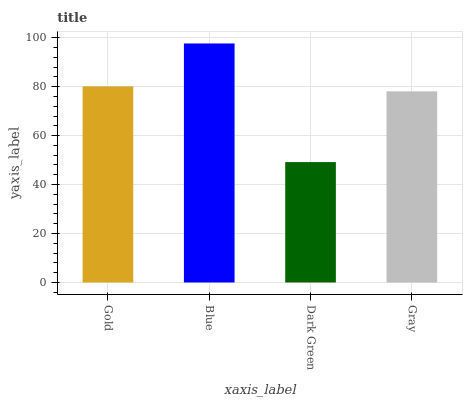Is Dark Green the minimum?
Answer yes or no. Yes. Is Blue the maximum?
Answer yes or no. Yes. Is Blue the minimum?
Answer yes or no. No. Is Dark Green the maximum?
Answer yes or no. No. Is Blue greater than Dark Green?
Answer yes or no. Yes. Is Dark Green less than Blue?
Answer yes or no. Yes. Is Dark Green greater than Blue?
Answer yes or no. No. Is Blue less than Dark Green?
Answer yes or no. No. Is Gold the high median?
Answer yes or no. Yes. Is Gray the low median?
Answer yes or no. Yes. Is Gray the high median?
Answer yes or no. No. Is Blue the low median?
Answer yes or no. No. 